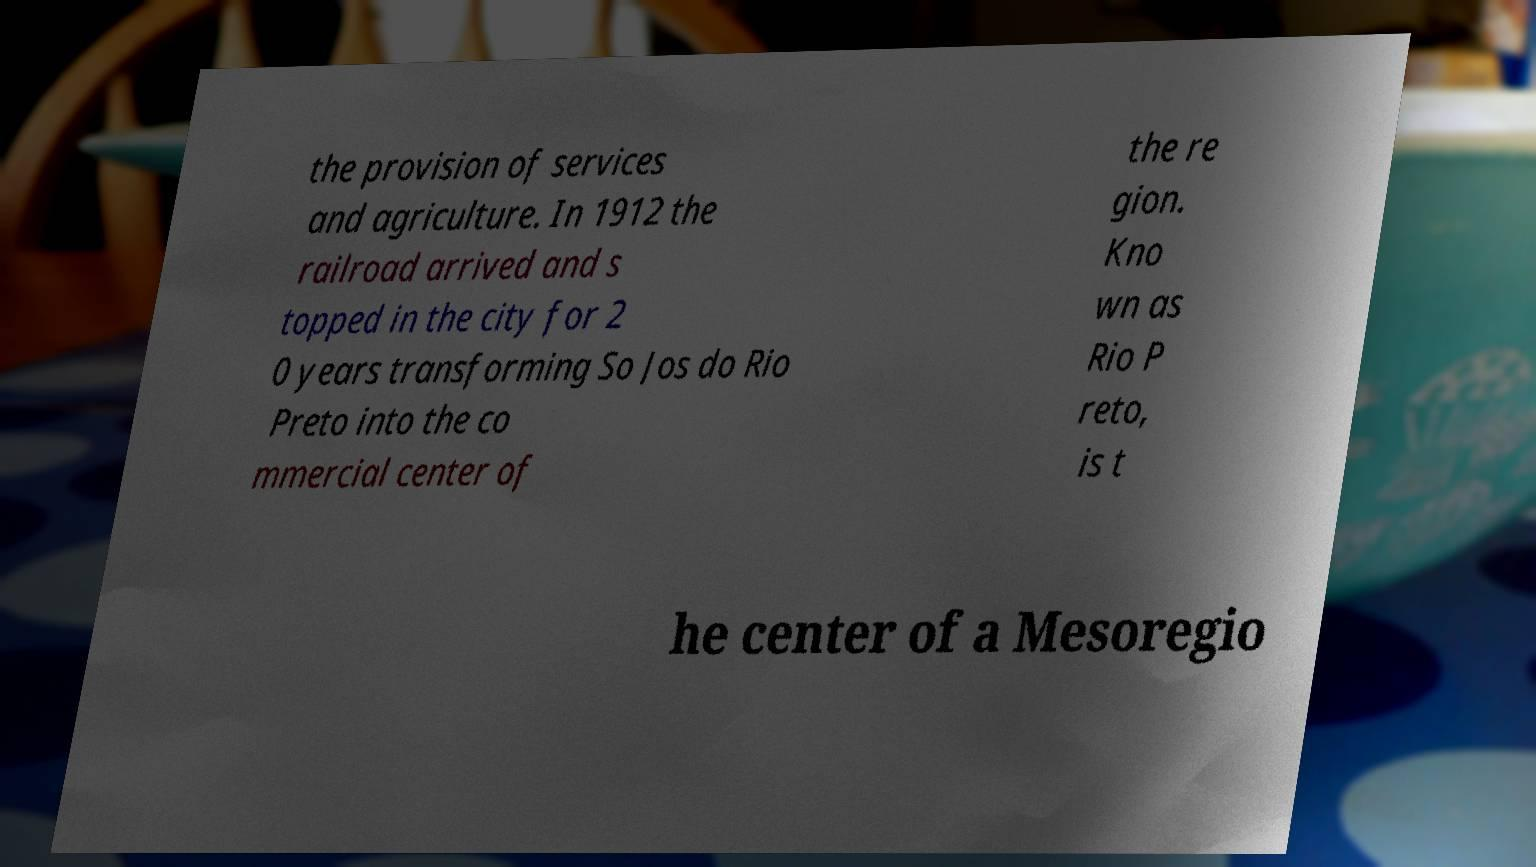Can you read and provide the text displayed in the image?This photo seems to have some interesting text. Can you extract and type it out for me? the provision of services and agriculture. In 1912 the railroad arrived and s topped in the city for 2 0 years transforming So Jos do Rio Preto into the co mmercial center of the re gion. Kno wn as Rio P reto, is t he center of a Mesoregio 